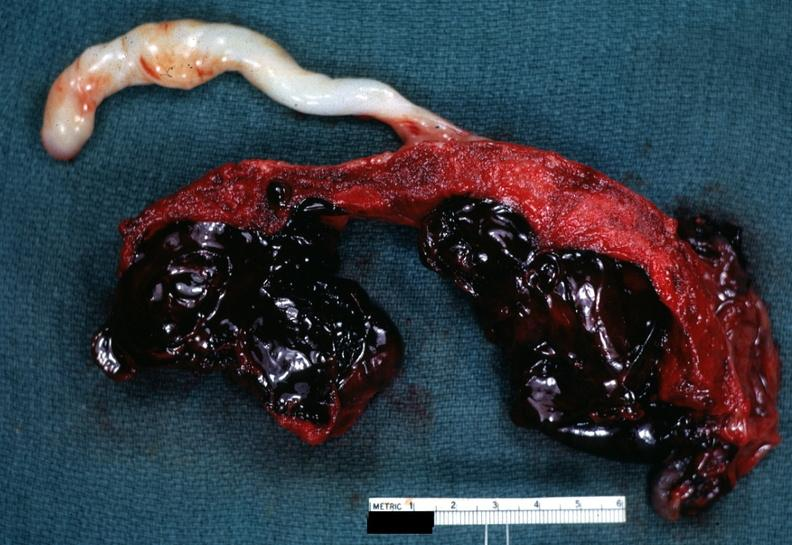s female reproductive present?
Answer the question using a single word or phrase. Yes 